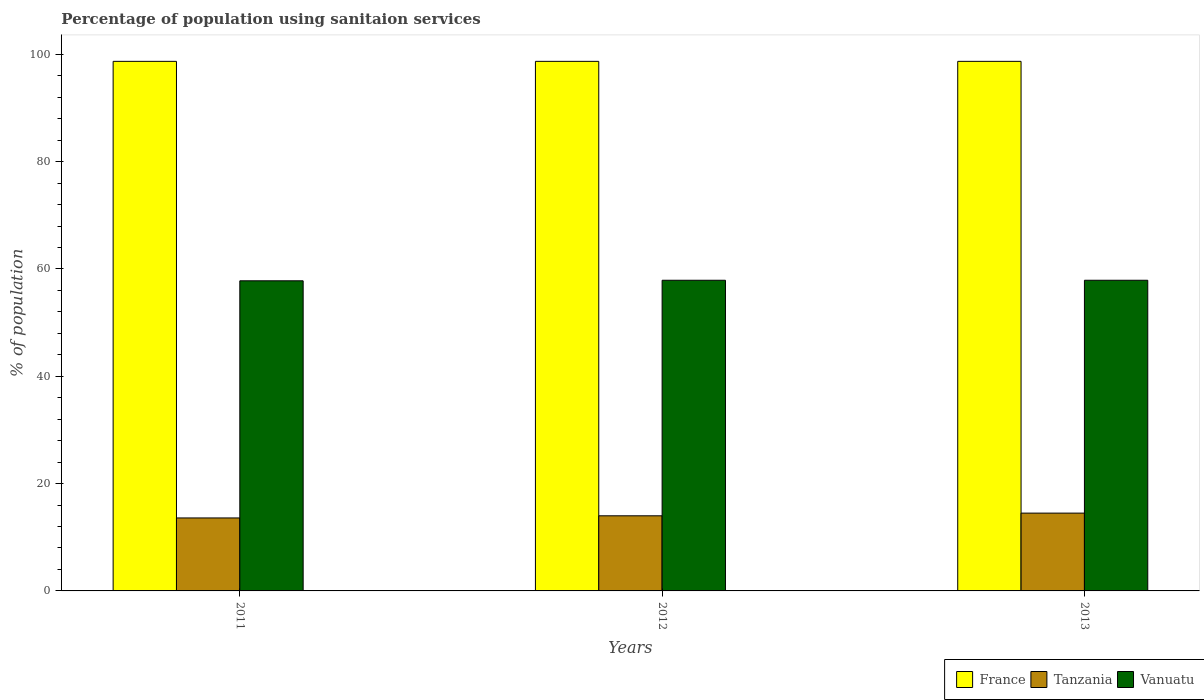How many different coloured bars are there?
Offer a very short reply. 3. Are the number of bars per tick equal to the number of legend labels?
Make the answer very short. Yes. Are the number of bars on each tick of the X-axis equal?
Offer a terse response. Yes. What is the percentage of population using sanitaion services in France in 2011?
Offer a very short reply. 98.7. Across all years, what is the maximum percentage of population using sanitaion services in Vanuatu?
Provide a succinct answer. 57.9. Across all years, what is the minimum percentage of population using sanitaion services in Tanzania?
Make the answer very short. 13.6. In which year was the percentage of population using sanitaion services in France minimum?
Ensure brevity in your answer.  2011. What is the total percentage of population using sanitaion services in France in the graph?
Ensure brevity in your answer.  296.1. What is the difference between the percentage of population using sanitaion services in Vanuatu in 2011 and that in 2012?
Make the answer very short. -0.1. What is the difference between the percentage of population using sanitaion services in Vanuatu in 2012 and the percentage of population using sanitaion services in Tanzania in 2013?
Give a very brief answer. 43.4. What is the average percentage of population using sanitaion services in Tanzania per year?
Provide a short and direct response. 14.03. In the year 2012, what is the difference between the percentage of population using sanitaion services in France and percentage of population using sanitaion services in Tanzania?
Provide a succinct answer. 84.7. In how many years, is the percentage of population using sanitaion services in Vanuatu greater than 72 %?
Keep it short and to the point. 0. Is the percentage of population using sanitaion services in France in 2011 less than that in 2012?
Your answer should be compact. No. What is the difference between the highest and the lowest percentage of population using sanitaion services in Tanzania?
Offer a very short reply. 0.9. In how many years, is the percentage of population using sanitaion services in Tanzania greater than the average percentage of population using sanitaion services in Tanzania taken over all years?
Ensure brevity in your answer.  1. Is the sum of the percentage of population using sanitaion services in Tanzania in 2012 and 2013 greater than the maximum percentage of population using sanitaion services in Vanuatu across all years?
Give a very brief answer. No. What does the 1st bar from the left in 2012 represents?
Your response must be concise. France. How many bars are there?
Ensure brevity in your answer.  9. Does the graph contain any zero values?
Provide a short and direct response. No. Does the graph contain grids?
Provide a succinct answer. No. Where does the legend appear in the graph?
Your answer should be compact. Bottom right. How many legend labels are there?
Give a very brief answer. 3. What is the title of the graph?
Give a very brief answer. Percentage of population using sanitaion services. What is the label or title of the X-axis?
Keep it short and to the point. Years. What is the label or title of the Y-axis?
Your answer should be very brief. % of population. What is the % of population of France in 2011?
Keep it short and to the point. 98.7. What is the % of population of Tanzania in 2011?
Provide a short and direct response. 13.6. What is the % of population in Vanuatu in 2011?
Make the answer very short. 57.8. What is the % of population in France in 2012?
Offer a terse response. 98.7. What is the % of population in Vanuatu in 2012?
Keep it short and to the point. 57.9. What is the % of population in France in 2013?
Your answer should be compact. 98.7. What is the % of population of Vanuatu in 2013?
Your answer should be compact. 57.9. Across all years, what is the maximum % of population in France?
Offer a terse response. 98.7. Across all years, what is the maximum % of population of Tanzania?
Ensure brevity in your answer.  14.5. Across all years, what is the maximum % of population of Vanuatu?
Your response must be concise. 57.9. Across all years, what is the minimum % of population of France?
Keep it short and to the point. 98.7. Across all years, what is the minimum % of population in Tanzania?
Provide a short and direct response. 13.6. Across all years, what is the minimum % of population of Vanuatu?
Your answer should be very brief. 57.8. What is the total % of population in France in the graph?
Offer a terse response. 296.1. What is the total % of population of Tanzania in the graph?
Your response must be concise. 42.1. What is the total % of population in Vanuatu in the graph?
Provide a short and direct response. 173.6. What is the difference between the % of population in France in 2011 and that in 2012?
Your answer should be compact. 0. What is the difference between the % of population in Tanzania in 2011 and that in 2012?
Give a very brief answer. -0.4. What is the difference between the % of population in France in 2012 and that in 2013?
Make the answer very short. 0. What is the difference between the % of population of Vanuatu in 2012 and that in 2013?
Ensure brevity in your answer.  0. What is the difference between the % of population of France in 2011 and the % of population of Tanzania in 2012?
Keep it short and to the point. 84.7. What is the difference between the % of population in France in 2011 and the % of population in Vanuatu in 2012?
Offer a very short reply. 40.8. What is the difference between the % of population in Tanzania in 2011 and the % of population in Vanuatu in 2012?
Provide a succinct answer. -44.3. What is the difference between the % of population in France in 2011 and the % of population in Tanzania in 2013?
Ensure brevity in your answer.  84.2. What is the difference between the % of population in France in 2011 and the % of population in Vanuatu in 2013?
Make the answer very short. 40.8. What is the difference between the % of population in Tanzania in 2011 and the % of population in Vanuatu in 2013?
Your answer should be very brief. -44.3. What is the difference between the % of population in France in 2012 and the % of population in Tanzania in 2013?
Make the answer very short. 84.2. What is the difference between the % of population in France in 2012 and the % of population in Vanuatu in 2013?
Ensure brevity in your answer.  40.8. What is the difference between the % of population in Tanzania in 2012 and the % of population in Vanuatu in 2013?
Offer a very short reply. -43.9. What is the average % of population of France per year?
Give a very brief answer. 98.7. What is the average % of population in Tanzania per year?
Offer a very short reply. 14.03. What is the average % of population of Vanuatu per year?
Give a very brief answer. 57.87. In the year 2011, what is the difference between the % of population in France and % of population in Tanzania?
Keep it short and to the point. 85.1. In the year 2011, what is the difference between the % of population in France and % of population in Vanuatu?
Keep it short and to the point. 40.9. In the year 2011, what is the difference between the % of population of Tanzania and % of population of Vanuatu?
Your response must be concise. -44.2. In the year 2012, what is the difference between the % of population of France and % of population of Tanzania?
Provide a short and direct response. 84.7. In the year 2012, what is the difference between the % of population in France and % of population in Vanuatu?
Your response must be concise. 40.8. In the year 2012, what is the difference between the % of population in Tanzania and % of population in Vanuatu?
Offer a terse response. -43.9. In the year 2013, what is the difference between the % of population of France and % of population of Tanzania?
Offer a very short reply. 84.2. In the year 2013, what is the difference between the % of population in France and % of population in Vanuatu?
Offer a terse response. 40.8. In the year 2013, what is the difference between the % of population of Tanzania and % of population of Vanuatu?
Your answer should be compact. -43.4. What is the ratio of the % of population of France in 2011 to that in 2012?
Make the answer very short. 1. What is the ratio of the % of population of Tanzania in 2011 to that in 2012?
Provide a short and direct response. 0.97. What is the ratio of the % of population in France in 2011 to that in 2013?
Provide a short and direct response. 1. What is the ratio of the % of population of Tanzania in 2011 to that in 2013?
Your answer should be compact. 0.94. What is the ratio of the % of population in France in 2012 to that in 2013?
Provide a short and direct response. 1. What is the ratio of the % of population of Tanzania in 2012 to that in 2013?
Give a very brief answer. 0.97. What is the difference between the highest and the second highest % of population of France?
Your answer should be very brief. 0. What is the difference between the highest and the second highest % of population in Vanuatu?
Your answer should be compact. 0. What is the difference between the highest and the lowest % of population in France?
Give a very brief answer. 0. What is the difference between the highest and the lowest % of population of Vanuatu?
Your response must be concise. 0.1. 